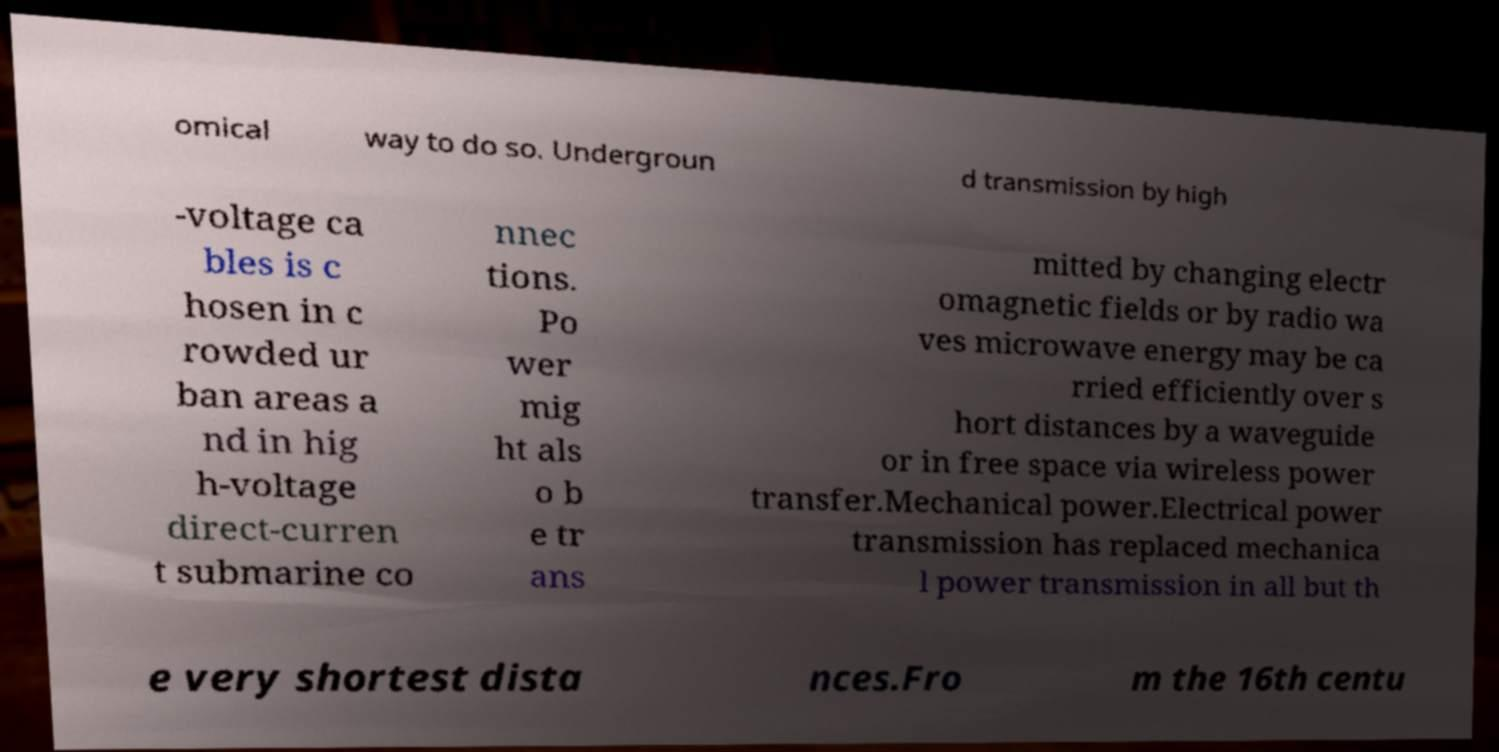For documentation purposes, I need the text within this image transcribed. Could you provide that? omical way to do so. Undergroun d transmission by high -voltage ca bles is c hosen in c rowded ur ban areas a nd in hig h-voltage direct-curren t submarine co nnec tions. Po wer mig ht als o b e tr ans mitted by changing electr omagnetic fields or by radio wa ves microwave energy may be ca rried efficiently over s hort distances by a waveguide or in free space via wireless power transfer.Mechanical power.Electrical power transmission has replaced mechanica l power transmission in all but th e very shortest dista nces.Fro m the 16th centu 